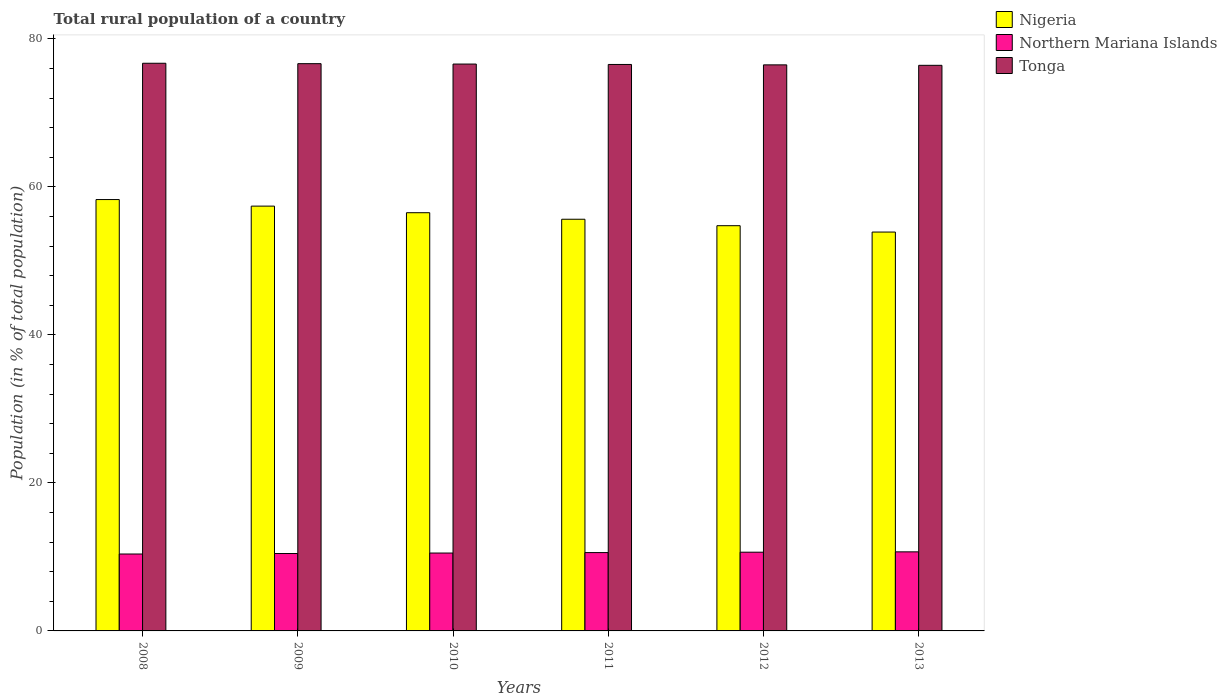How many groups of bars are there?
Offer a terse response. 6. Are the number of bars per tick equal to the number of legend labels?
Your response must be concise. Yes. Are the number of bars on each tick of the X-axis equal?
Provide a short and direct response. Yes. How many bars are there on the 6th tick from the left?
Your answer should be compact. 3. What is the rural population in Nigeria in 2008?
Provide a succinct answer. 58.3. Across all years, what is the maximum rural population in Tonga?
Ensure brevity in your answer.  76.72. Across all years, what is the minimum rural population in Tonga?
Offer a very short reply. 76.44. In which year was the rural population in Tonga maximum?
Provide a succinct answer. 2008. What is the total rural population in Tonga in the graph?
Provide a succinct answer. 459.49. What is the difference between the rural population in Northern Mariana Islands in 2011 and that in 2012?
Your response must be concise. -0.05. What is the difference between the rural population in Northern Mariana Islands in 2008 and the rural population in Tonga in 2010?
Your answer should be very brief. -66.22. What is the average rural population in Nigeria per year?
Your answer should be compact. 56.09. In the year 2010, what is the difference between the rural population in Tonga and rural population in Northern Mariana Islands?
Provide a short and direct response. 66.09. In how many years, is the rural population in Tonga greater than 52 %?
Give a very brief answer. 6. What is the ratio of the rural population in Nigeria in 2008 to that in 2011?
Your answer should be compact. 1.05. Is the difference between the rural population in Tonga in 2008 and 2010 greater than the difference between the rural population in Northern Mariana Islands in 2008 and 2010?
Your answer should be very brief. Yes. What is the difference between the highest and the second highest rural population in Nigeria?
Ensure brevity in your answer.  0.89. What is the difference between the highest and the lowest rural population in Tonga?
Offer a very short reply. 0.28. In how many years, is the rural population in Nigeria greater than the average rural population in Nigeria taken over all years?
Your answer should be compact. 3. What does the 2nd bar from the left in 2012 represents?
Your answer should be compact. Northern Mariana Islands. What does the 2nd bar from the right in 2010 represents?
Make the answer very short. Northern Mariana Islands. How many bars are there?
Provide a short and direct response. 18. Are all the bars in the graph horizontal?
Ensure brevity in your answer.  No. Does the graph contain grids?
Offer a very short reply. No. How many legend labels are there?
Offer a terse response. 3. How are the legend labels stacked?
Your answer should be very brief. Vertical. What is the title of the graph?
Offer a very short reply. Total rural population of a country. What is the label or title of the X-axis?
Offer a terse response. Years. What is the label or title of the Y-axis?
Provide a succinct answer. Population (in % of total population). What is the Population (in % of total population) in Nigeria in 2008?
Provide a short and direct response. 58.3. What is the Population (in % of total population) of Northern Mariana Islands in 2008?
Provide a succinct answer. 10.39. What is the Population (in % of total population) in Tonga in 2008?
Your answer should be very brief. 76.72. What is the Population (in % of total population) of Nigeria in 2009?
Ensure brevity in your answer.  57.41. What is the Population (in % of total population) of Northern Mariana Islands in 2009?
Your answer should be very brief. 10.46. What is the Population (in % of total population) in Tonga in 2009?
Offer a terse response. 76.67. What is the Population (in % of total population) of Nigeria in 2010?
Make the answer very short. 56.52. What is the Population (in % of total population) of Northern Mariana Islands in 2010?
Your answer should be very brief. 10.53. What is the Population (in % of total population) in Tonga in 2010?
Make the answer very short. 76.61. What is the Population (in % of total population) of Nigeria in 2011?
Your answer should be compact. 55.64. What is the Population (in % of total population) of Northern Mariana Islands in 2011?
Your response must be concise. 10.59. What is the Population (in % of total population) in Tonga in 2011?
Your answer should be very brief. 76.56. What is the Population (in % of total population) of Nigeria in 2012?
Offer a very short reply. 54.77. What is the Population (in % of total population) of Northern Mariana Islands in 2012?
Your response must be concise. 10.64. What is the Population (in % of total population) in Tonga in 2012?
Your answer should be very brief. 76.5. What is the Population (in % of total population) in Nigeria in 2013?
Make the answer very short. 53.91. What is the Population (in % of total population) of Northern Mariana Islands in 2013?
Offer a terse response. 10.69. What is the Population (in % of total population) in Tonga in 2013?
Your answer should be compact. 76.44. Across all years, what is the maximum Population (in % of total population) of Nigeria?
Your response must be concise. 58.3. Across all years, what is the maximum Population (in % of total population) of Northern Mariana Islands?
Offer a terse response. 10.69. Across all years, what is the maximum Population (in % of total population) of Tonga?
Provide a succinct answer. 76.72. Across all years, what is the minimum Population (in % of total population) of Nigeria?
Provide a short and direct response. 53.91. Across all years, what is the minimum Population (in % of total population) in Northern Mariana Islands?
Your answer should be compact. 10.39. Across all years, what is the minimum Population (in % of total population) in Tonga?
Provide a short and direct response. 76.44. What is the total Population (in % of total population) of Nigeria in the graph?
Offer a very short reply. 336.54. What is the total Population (in % of total population) in Northern Mariana Islands in the graph?
Provide a short and direct response. 63.3. What is the total Population (in % of total population) of Tonga in the graph?
Provide a succinct answer. 459.49. What is the difference between the Population (in % of total population) in Nigeria in 2008 and that in 2009?
Ensure brevity in your answer.  0.89. What is the difference between the Population (in % of total population) of Northern Mariana Islands in 2008 and that in 2009?
Provide a short and direct response. -0.07. What is the difference between the Population (in % of total population) in Tonga in 2008 and that in 2009?
Ensure brevity in your answer.  0.05. What is the difference between the Population (in % of total population) in Nigeria in 2008 and that in 2010?
Your response must be concise. 1.78. What is the difference between the Population (in % of total population) of Northern Mariana Islands in 2008 and that in 2010?
Your response must be concise. -0.13. What is the difference between the Population (in % of total population) in Tonga in 2008 and that in 2010?
Provide a short and direct response. 0.11. What is the difference between the Population (in % of total population) of Nigeria in 2008 and that in 2011?
Your response must be concise. 2.66. What is the difference between the Population (in % of total population) of Northern Mariana Islands in 2008 and that in 2011?
Your response must be concise. -0.19. What is the difference between the Population (in % of total population) of Tonga in 2008 and that in 2011?
Your response must be concise. 0.16. What is the difference between the Population (in % of total population) of Nigeria in 2008 and that in 2012?
Keep it short and to the point. 3.53. What is the difference between the Population (in % of total population) of Northern Mariana Islands in 2008 and that in 2012?
Offer a very short reply. -0.24. What is the difference between the Population (in % of total population) of Tonga in 2008 and that in 2012?
Give a very brief answer. 0.22. What is the difference between the Population (in % of total population) in Nigeria in 2008 and that in 2013?
Provide a succinct answer. 4.39. What is the difference between the Population (in % of total population) of Northern Mariana Islands in 2008 and that in 2013?
Offer a very short reply. -0.29. What is the difference between the Population (in % of total population) in Tonga in 2008 and that in 2013?
Your response must be concise. 0.28. What is the difference between the Population (in % of total population) in Nigeria in 2009 and that in 2010?
Your answer should be very brief. 0.89. What is the difference between the Population (in % of total population) in Northern Mariana Islands in 2009 and that in 2010?
Your response must be concise. -0.07. What is the difference between the Population (in % of total population) of Tonga in 2009 and that in 2010?
Offer a terse response. 0.05. What is the difference between the Population (in % of total population) of Nigeria in 2009 and that in 2011?
Keep it short and to the point. 1.77. What is the difference between the Population (in % of total population) of Northern Mariana Islands in 2009 and that in 2011?
Provide a succinct answer. -0.12. What is the difference between the Population (in % of total population) in Tonga in 2009 and that in 2011?
Keep it short and to the point. 0.11. What is the difference between the Population (in % of total population) in Nigeria in 2009 and that in 2012?
Offer a very short reply. 2.65. What is the difference between the Population (in % of total population) of Northern Mariana Islands in 2009 and that in 2012?
Keep it short and to the point. -0.18. What is the difference between the Population (in % of total population) of Tonga in 2009 and that in 2012?
Ensure brevity in your answer.  0.16. What is the difference between the Population (in % of total population) in Nigeria in 2009 and that in 2013?
Provide a succinct answer. 3.51. What is the difference between the Population (in % of total population) of Northern Mariana Islands in 2009 and that in 2013?
Your answer should be very brief. -0.23. What is the difference between the Population (in % of total population) of Tonga in 2009 and that in 2013?
Provide a succinct answer. 0.23. What is the difference between the Population (in % of total population) in Nigeria in 2010 and that in 2011?
Provide a succinct answer. 0.88. What is the difference between the Population (in % of total population) in Northern Mariana Islands in 2010 and that in 2011?
Give a very brief answer. -0.06. What is the difference between the Population (in % of total population) in Tonga in 2010 and that in 2011?
Keep it short and to the point. 0.05. What is the difference between the Population (in % of total population) of Nigeria in 2010 and that in 2012?
Offer a very short reply. 1.75. What is the difference between the Population (in % of total population) in Northern Mariana Islands in 2010 and that in 2012?
Ensure brevity in your answer.  -0.11. What is the difference between the Population (in % of total population) in Tonga in 2010 and that in 2012?
Give a very brief answer. 0.11. What is the difference between the Population (in % of total population) in Nigeria in 2010 and that in 2013?
Provide a succinct answer. 2.61. What is the difference between the Population (in % of total population) of Northern Mariana Islands in 2010 and that in 2013?
Your answer should be very brief. -0.16. What is the difference between the Population (in % of total population) of Tonga in 2010 and that in 2013?
Make the answer very short. 0.17. What is the difference between the Population (in % of total population) in Nigeria in 2011 and that in 2012?
Give a very brief answer. 0.87. What is the difference between the Population (in % of total population) in Northern Mariana Islands in 2011 and that in 2012?
Offer a terse response. -0.05. What is the difference between the Population (in % of total population) in Tonga in 2011 and that in 2012?
Make the answer very short. 0.06. What is the difference between the Population (in % of total population) in Nigeria in 2011 and that in 2013?
Give a very brief answer. 1.73. What is the difference between the Population (in % of total population) in Northern Mariana Islands in 2011 and that in 2013?
Give a very brief answer. -0.1. What is the difference between the Population (in % of total population) of Tonga in 2011 and that in 2013?
Offer a terse response. 0.12. What is the difference between the Population (in % of total population) of Nigeria in 2012 and that in 2013?
Your answer should be very brief. 0.86. What is the difference between the Population (in % of total population) in Northern Mariana Islands in 2012 and that in 2013?
Your response must be concise. -0.05. What is the difference between the Population (in % of total population) of Tonga in 2012 and that in 2013?
Make the answer very short. 0.06. What is the difference between the Population (in % of total population) in Nigeria in 2008 and the Population (in % of total population) in Northern Mariana Islands in 2009?
Provide a succinct answer. 47.84. What is the difference between the Population (in % of total population) of Nigeria in 2008 and the Population (in % of total population) of Tonga in 2009?
Your response must be concise. -18.37. What is the difference between the Population (in % of total population) in Northern Mariana Islands in 2008 and the Population (in % of total population) in Tonga in 2009?
Your answer should be compact. -66.27. What is the difference between the Population (in % of total population) of Nigeria in 2008 and the Population (in % of total population) of Northern Mariana Islands in 2010?
Provide a succinct answer. 47.77. What is the difference between the Population (in % of total population) of Nigeria in 2008 and the Population (in % of total population) of Tonga in 2010?
Provide a short and direct response. -18.31. What is the difference between the Population (in % of total population) in Northern Mariana Islands in 2008 and the Population (in % of total population) in Tonga in 2010?
Your response must be concise. -66.22. What is the difference between the Population (in % of total population) in Nigeria in 2008 and the Population (in % of total population) in Northern Mariana Islands in 2011?
Make the answer very short. 47.71. What is the difference between the Population (in % of total population) in Nigeria in 2008 and the Population (in % of total population) in Tonga in 2011?
Make the answer very short. -18.26. What is the difference between the Population (in % of total population) of Northern Mariana Islands in 2008 and the Population (in % of total population) of Tonga in 2011?
Your answer should be compact. -66.16. What is the difference between the Population (in % of total population) in Nigeria in 2008 and the Population (in % of total population) in Northern Mariana Islands in 2012?
Keep it short and to the point. 47.66. What is the difference between the Population (in % of total population) of Nigeria in 2008 and the Population (in % of total population) of Tonga in 2012?
Keep it short and to the point. -18.2. What is the difference between the Population (in % of total population) of Northern Mariana Islands in 2008 and the Population (in % of total population) of Tonga in 2012?
Make the answer very short. -66.11. What is the difference between the Population (in % of total population) in Nigeria in 2008 and the Population (in % of total population) in Northern Mariana Islands in 2013?
Make the answer very short. 47.61. What is the difference between the Population (in % of total population) in Nigeria in 2008 and the Population (in % of total population) in Tonga in 2013?
Provide a short and direct response. -18.14. What is the difference between the Population (in % of total population) in Northern Mariana Islands in 2008 and the Population (in % of total population) in Tonga in 2013?
Offer a terse response. -66.05. What is the difference between the Population (in % of total population) of Nigeria in 2009 and the Population (in % of total population) of Northern Mariana Islands in 2010?
Offer a very short reply. 46.89. What is the difference between the Population (in % of total population) of Nigeria in 2009 and the Population (in % of total population) of Tonga in 2010?
Your response must be concise. -19.2. What is the difference between the Population (in % of total population) in Northern Mariana Islands in 2009 and the Population (in % of total population) in Tonga in 2010?
Ensure brevity in your answer.  -66.15. What is the difference between the Population (in % of total population) of Nigeria in 2009 and the Population (in % of total population) of Northern Mariana Islands in 2011?
Give a very brief answer. 46.83. What is the difference between the Population (in % of total population) in Nigeria in 2009 and the Population (in % of total population) in Tonga in 2011?
Provide a short and direct response. -19.14. What is the difference between the Population (in % of total population) in Northern Mariana Islands in 2009 and the Population (in % of total population) in Tonga in 2011?
Provide a short and direct response. -66.1. What is the difference between the Population (in % of total population) in Nigeria in 2009 and the Population (in % of total population) in Northern Mariana Islands in 2012?
Keep it short and to the point. 46.77. What is the difference between the Population (in % of total population) of Nigeria in 2009 and the Population (in % of total population) of Tonga in 2012?
Your answer should be compact. -19.09. What is the difference between the Population (in % of total population) of Northern Mariana Islands in 2009 and the Population (in % of total population) of Tonga in 2012?
Give a very brief answer. -66.04. What is the difference between the Population (in % of total population) of Nigeria in 2009 and the Population (in % of total population) of Northern Mariana Islands in 2013?
Offer a very short reply. 46.73. What is the difference between the Population (in % of total population) of Nigeria in 2009 and the Population (in % of total population) of Tonga in 2013?
Give a very brief answer. -19.03. What is the difference between the Population (in % of total population) of Northern Mariana Islands in 2009 and the Population (in % of total population) of Tonga in 2013?
Your answer should be compact. -65.98. What is the difference between the Population (in % of total population) of Nigeria in 2010 and the Population (in % of total population) of Northern Mariana Islands in 2011?
Your answer should be very brief. 45.93. What is the difference between the Population (in % of total population) of Nigeria in 2010 and the Population (in % of total population) of Tonga in 2011?
Give a very brief answer. -20.04. What is the difference between the Population (in % of total population) of Northern Mariana Islands in 2010 and the Population (in % of total population) of Tonga in 2011?
Your answer should be very brief. -66.03. What is the difference between the Population (in % of total population) of Nigeria in 2010 and the Population (in % of total population) of Northern Mariana Islands in 2012?
Your response must be concise. 45.88. What is the difference between the Population (in % of total population) of Nigeria in 2010 and the Population (in % of total population) of Tonga in 2012?
Give a very brief answer. -19.98. What is the difference between the Population (in % of total population) in Northern Mariana Islands in 2010 and the Population (in % of total population) in Tonga in 2012?
Your response must be concise. -65.98. What is the difference between the Population (in % of total population) in Nigeria in 2010 and the Population (in % of total population) in Northern Mariana Islands in 2013?
Your response must be concise. 45.83. What is the difference between the Population (in % of total population) of Nigeria in 2010 and the Population (in % of total population) of Tonga in 2013?
Your answer should be very brief. -19.92. What is the difference between the Population (in % of total population) in Northern Mariana Islands in 2010 and the Population (in % of total population) in Tonga in 2013?
Your answer should be very brief. -65.91. What is the difference between the Population (in % of total population) of Nigeria in 2011 and the Population (in % of total population) of Northern Mariana Islands in 2012?
Provide a short and direct response. 45. What is the difference between the Population (in % of total population) of Nigeria in 2011 and the Population (in % of total population) of Tonga in 2012?
Provide a short and direct response. -20.86. What is the difference between the Population (in % of total population) in Northern Mariana Islands in 2011 and the Population (in % of total population) in Tonga in 2012?
Your response must be concise. -65.92. What is the difference between the Population (in % of total population) in Nigeria in 2011 and the Population (in % of total population) in Northern Mariana Islands in 2013?
Offer a terse response. 44.95. What is the difference between the Population (in % of total population) in Nigeria in 2011 and the Population (in % of total population) in Tonga in 2013?
Offer a terse response. -20.8. What is the difference between the Population (in % of total population) of Northern Mariana Islands in 2011 and the Population (in % of total population) of Tonga in 2013?
Your answer should be very brief. -65.85. What is the difference between the Population (in % of total population) in Nigeria in 2012 and the Population (in % of total population) in Northern Mariana Islands in 2013?
Your answer should be compact. 44.08. What is the difference between the Population (in % of total population) of Nigeria in 2012 and the Population (in % of total population) of Tonga in 2013?
Provide a short and direct response. -21.67. What is the difference between the Population (in % of total population) of Northern Mariana Islands in 2012 and the Population (in % of total population) of Tonga in 2013?
Your response must be concise. -65.8. What is the average Population (in % of total population) of Nigeria per year?
Make the answer very short. 56.09. What is the average Population (in % of total population) in Northern Mariana Islands per year?
Offer a terse response. 10.55. What is the average Population (in % of total population) in Tonga per year?
Offer a very short reply. 76.58. In the year 2008, what is the difference between the Population (in % of total population) of Nigeria and Population (in % of total population) of Northern Mariana Islands?
Your answer should be compact. 47.9. In the year 2008, what is the difference between the Population (in % of total population) of Nigeria and Population (in % of total population) of Tonga?
Make the answer very short. -18.42. In the year 2008, what is the difference between the Population (in % of total population) of Northern Mariana Islands and Population (in % of total population) of Tonga?
Ensure brevity in your answer.  -66.32. In the year 2009, what is the difference between the Population (in % of total population) in Nigeria and Population (in % of total population) in Northern Mariana Islands?
Your response must be concise. 46.95. In the year 2009, what is the difference between the Population (in % of total population) in Nigeria and Population (in % of total population) in Tonga?
Provide a succinct answer. -19.25. In the year 2009, what is the difference between the Population (in % of total population) in Northern Mariana Islands and Population (in % of total population) in Tonga?
Keep it short and to the point. -66.2. In the year 2010, what is the difference between the Population (in % of total population) of Nigeria and Population (in % of total population) of Northern Mariana Islands?
Keep it short and to the point. 45.99. In the year 2010, what is the difference between the Population (in % of total population) of Nigeria and Population (in % of total population) of Tonga?
Provide a short and direct response. -20.09. In the year 2010, what is the difference between the Population (in % of total population) of Northern Mariana Islands and Population (in % of total population) of Tonga?
Offer a terse response. -66.08. In the year 2011, what is the difference between the Population (in % of total population) in Nigeria and Population (in % of total population) in Northern Mariana Islands?
Make the answer very short. 45.05. In the year 2011, what is the difference between the Population (in % of total population) of Nigeria and Population (in % of total population) of Tonga?
Your answer should be very brief. -20.92. In the year 2011, what is the difference between the Population (in % of total population) of Northern Mariana Islands and Population (in % of total population) of Tonga?
Ensure brevity in your answer.  -65.97. In the year 2012, what is the difference between the Population (in % of total population) in Nigeria and Population (in % of total population) in Northern Mariana Islands?
Your answer should be compact. 44.13. In the year 2012, what is the difference between the Population (in % of total population) of Nigeria and Population (in % of total population) of Tonga?
Ensure brevity in your answer.  -21.74. In the year 2012, what is the difference between the Population (in % of total population) in Northern Mariana Islands and Population (in % of total population) in Tonga?
Ensure brevity in your answer.  -65.86. In the year 2013, what is the difference between the Population (in % of total population) in Nigeria and Population (in % of total population) in Northern Mariana Islands?
Give a very brief answer. 43.22. In the year 2013, what is the difference between the Population (in % of total population) of Nigeria and Population (in % of total population) of Tonga?
Your response must be concise. -22.53. In the year 2013, what is the difference between the Population (in % of total population) in Northern Mariana Islands and Population (in % of total population) in Tonga?
Offer a terse response. -65.75. What is the ratio of the Population (in % of total population) of Nigeria in 2008 to that in 2009?
Offer a very short reply. 1.02. What is the ratio of the Population (in % of total population) in Tonga in 2008 to that in 2009?
Offer a terse response. 1. What is the ratio of the Population (in % of total population) in Nigeria in 2008 to that in 2010?
Make the answer very short. 1.03. What is the ratio of the Population (in % of total population) in Northern Mariana Islands in 2008 to that in 2010?
Provide a succinct answer. 0.99. What is the ratio of the Population (in % of total population) in Tonga in 2008 to that in 2010?
Ensure brevity in your answer.  1. What is the ratio of the Population (in % of total population) in Nigeria in 2008 to that in 2011?
Provide a succinct answer. 1.05. What is the ratio of the Population (in % of total population) in Northern Mariana Islands in 2008 to that in 2011?
Offer a terse response. 0.98. What is the ratio of the Population (in % of total population) in Tonga in 2008 to that in 2011?
Your response must be concise. 1. What is the ratio of the Population (in % of total population) of Nigeria in 2008 to that in 2012?
Your response must be concise. 1.06. What is the ratio of the Population (in % of total population) of Northern Mariana Islands in 2008 to that in 2012?
Your answer should be very brief. 0.98. What is the ratio of the Population (in % of total population) of Tonga in 2008 to that in 2012?
Give a very brief answer. 1. What is the ratio of the Population (in % of total population) in Nigeria in 2008 to that in 2013?
Provide a short and direct response. 1.08. What is the ratio of the Population (in % of total population) in Northern Mariana Islands in 2008 to that in 2013?
Ensure brevity in your answer.  0.97. What is the ratio of the Population (in % of total population) in Tonga in 2008 to that in 2013?
Offer a very short reply. 1. What is the ratio of the Population (in % of total population) of Nigeria in 2009 to that in 2010?
Your answer should be very brief. 1.02. What is the ratio of the Population (in % of total population) in Northern Mariana Islands in 2009 to that in 2010?
Offer a very short reply. 0.99. What is the ratio of the Population (in % of total population) of Tonga in 2009 to that in 2010?
Make the answer very short. 1. What is the ratio of the Population (in % of total population) in Nigeria in 2009 to that in 2011?
Offer a terse response. 1.03. What is the ratio of the Population (in % of total population) in Tonga in 2009 to that in 2011?
Your answer should be very brief. 1. What is the ratio of the Population (in % of total population) in Nigeria in 2009 to that in 2012?
Your answer should be very brief. 1.05. What is the ratio of the Population (in % of total population) in Northern Mariana Islands in 2009 to that in 2012?
Your response must be concise. 0.98. What is the ratio of the Population (in % of total population) in Nigeria in 2009 to that in 2013?
Your answer should be very brief. 1.06. What is the ratio of the Population (in % of total population) in Northern Mariana Islands in 2009 to that in 2013?
Provide a short and direct response. 0.98. What is the ratio of the Population (in % of total population) of Tonga in 2009 to that in 2013?
Your answer should be very brief. 1. What is the ratio of the Population (in % of total population) of Nigeria in 2010 to that in 2011?
Provide a succinct answer. 1.02. What is the ratio of the Population (in % of total population) of Tonga in 2010 to that in 2011?
Give a very brief answer. 1. What is the ratio of the Population (in % of total population) of Nigeria in 2010 to that in 2012?
Provide a short and direct response. 1.03. What is the ratio of the Population (in % of total population) of Northern Mariana Islands in 2010 to that in 2012?
Provide a succinct answer. 0.99. What is the ratio of the Population (in % of total population) in Tonga in 2010 to that in 2012?
Offer a very short reply. 1. What is the ratio of the Population (in % of total population) of Nigeria in 2010 to that in 2013?
Provide a succinct answer. 1.05. What is the ratio of the Population (in % of total population) of Northern Mariana Islands in 2010 to that in 2013?
Ensure brevity in your answer.  0.98. What is the ratio of the Population (in % of total population) in Tonga in 2010 to that in 2013?
Your response must be concise. 1. What is the ratio of the Population (in % of total population) in Nigeria in 2011 to that in 2012?
Offer a very short reply. 1.02. What is the ratio of the Population (in % of total population) in Northern Mariana Islands in 2011 to that in 2012?
Your answer should be very brief. 0.99. What is the ratio of the Population (in % of total population) of Nigeria in 2011 to that in 2013?
Provide a short and direct response. 1.03. What is the ratio of the Population (in % of total population) of Tonga in 2011 to that in 2013?
Your answer should be very brief. 1. What is the ratio of the Population (in % of total population) in Northern Mariana Islands in 2012 to that in 2013?
Keep it short and to the point. 1. What is the ratio of the Population (in % of total population) in Tonga in 2012 to that in 2013?
Offer a very short reply. 1. What is the difference between the highest and the second highest Population (in % of total population) in Nigeria?
Offer a very short reply. 0.89. What is the difference between the highest and the second highest Population (in % of total population) in Northern Mariana Islands?
Your response must be concise. 0.05. What is the difference between the highest and the second highest Population (in % of total population) in Tonga?
Your response must be concise. 0.05. What is the difference between the highest and the lowest Population (in % of total population) in Nigeria?
Provide a succinct answer. 4.39. What is the difference between the highest and the lowest Population (in % of total population) of Northern Mariana Islands?
Your answer should be compact. 0.29. What is the difference between the highest and the lowest Population (in % of total population) in Tonga?
Keep it short and to the point. 0.28. 